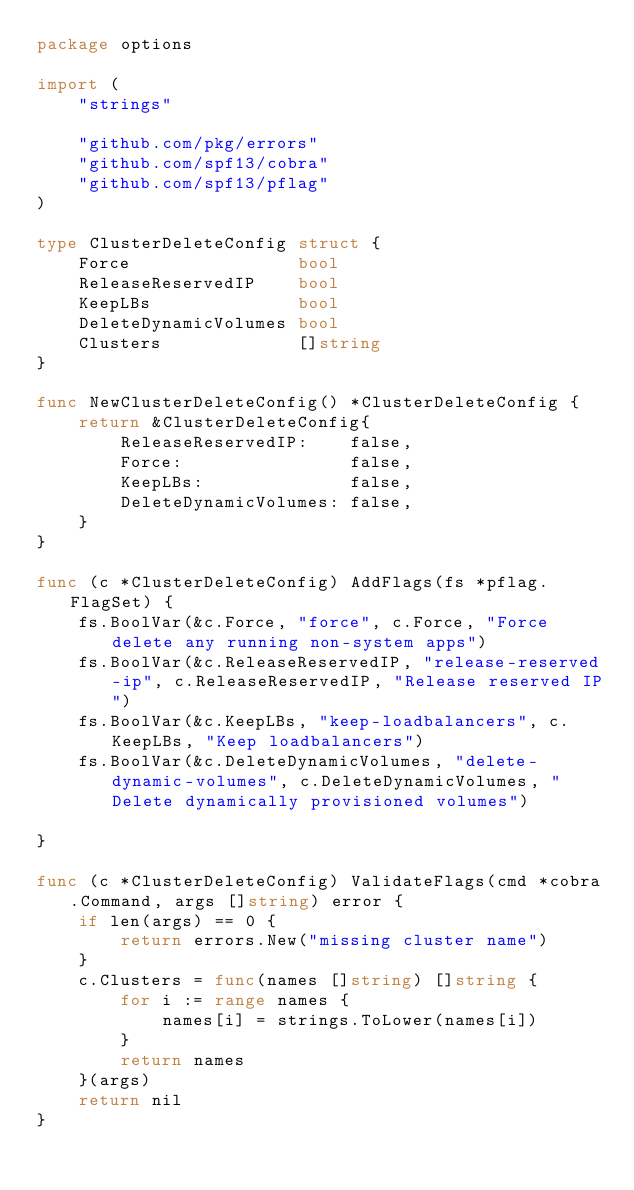Convert code to text. <code><loc_0><loc_0><loc_500><loc_500><_Go_>package options

import (
	"strings"

	"github.com/pkg/errors"
	"github.com/spf13/cobra"
	"github.com/spf13/pflag"
)

type ClusterDeleteConfig struct {
	Force                bool
	ReleaseReservedIP    bool
	KeepLBs              bool
	DeleteDynamicVolumes bool
	Clusters             []string
}

func NewClusterDeleteConfig() *ClusterDeleteConfig {
	return &ClusterDeleteConfig{
		ReleaseReservedIP:    false,
		Force:                false,
		KeepLBs:              false,
		DeleteDynamicVolumes: false,
	}
}

func (c *ClusterDeleteConfig) AddFlags(fs *pflag.FlagSet) {
	fs.BoolVar(&c.Force, "force", c.Force, "Force delete any running non-system apps")
	fs.BoolVar(&c.ReleaseReservedIP, "release-reserved-ip", c.ReleaseReservedIP, "Release reserved IP")
	fs.BoolVar(&c.KeepLBs, "keep-loadbalancers", c.KeepLBs, "Keep loadbalancers")
	fs.BoolVar(&c.DeleteDynamicVolumes, "delete-dynamic-volumes", c.DeleteDynamicVolumes, "Delete dynamically provisioned volumes")

}

func (c *ClusterDeleteConfig) ValidateFlags(cmd *cobra.Command, args []string) error {
	if len(args) == 0 {
		return errors.New("missing cluster name")
	}
	c.Clusters = func(names []string) []string {
		for i := range names {
			names[i] = strings.ToLower(names[i])
		}
		return names
	}(args)
	return nil
}
</code> 